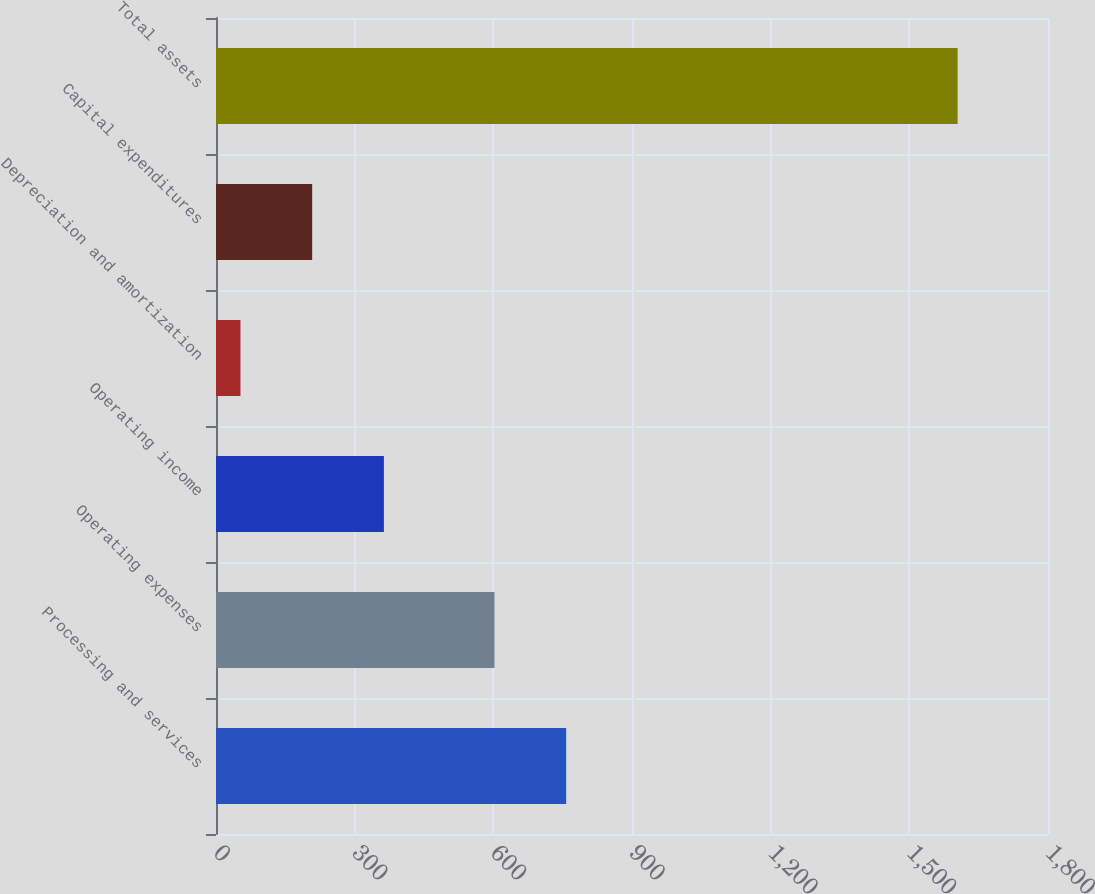<chart> <loc_0><loc_0><loc_500><loc_500><bar_chart><fcel>Processing and services<fcel>Operating expenses<fcel>Operating income<fcel>Depreciation and amortization<fcel>Capital expenditures<fcel>Total assets<nl><fcel>757.56<fcel>602.4<fcel>363.22<fcel>52.9<fcel>208.06<fcel>1604.5<nl></chart> 